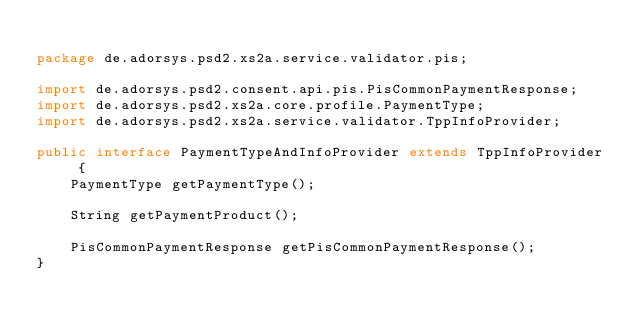Convert code to text. <code><loc_0><loc_0><loc_500><loc_500><_Java_>
package de.adorsys.psd2.xs2a.service.validator.pis;

import de.adorsys.psd2.consent.api.pis.PisCommonPaymentResponse;
import de.adorsys.psd2.xs2a.core.profile.PaymentType;
import de.adorsys.psd2.xs2a.service.validator.TppInfoProvider;

public interface PaymentTypeAndInfoProvider extends TppInfoProvider {
    PaymentType getPaymentType();

    String getPaymentProduct();

    PisCommonPaymentResponse getPisCommonPaymentResponse();
}
</code> 